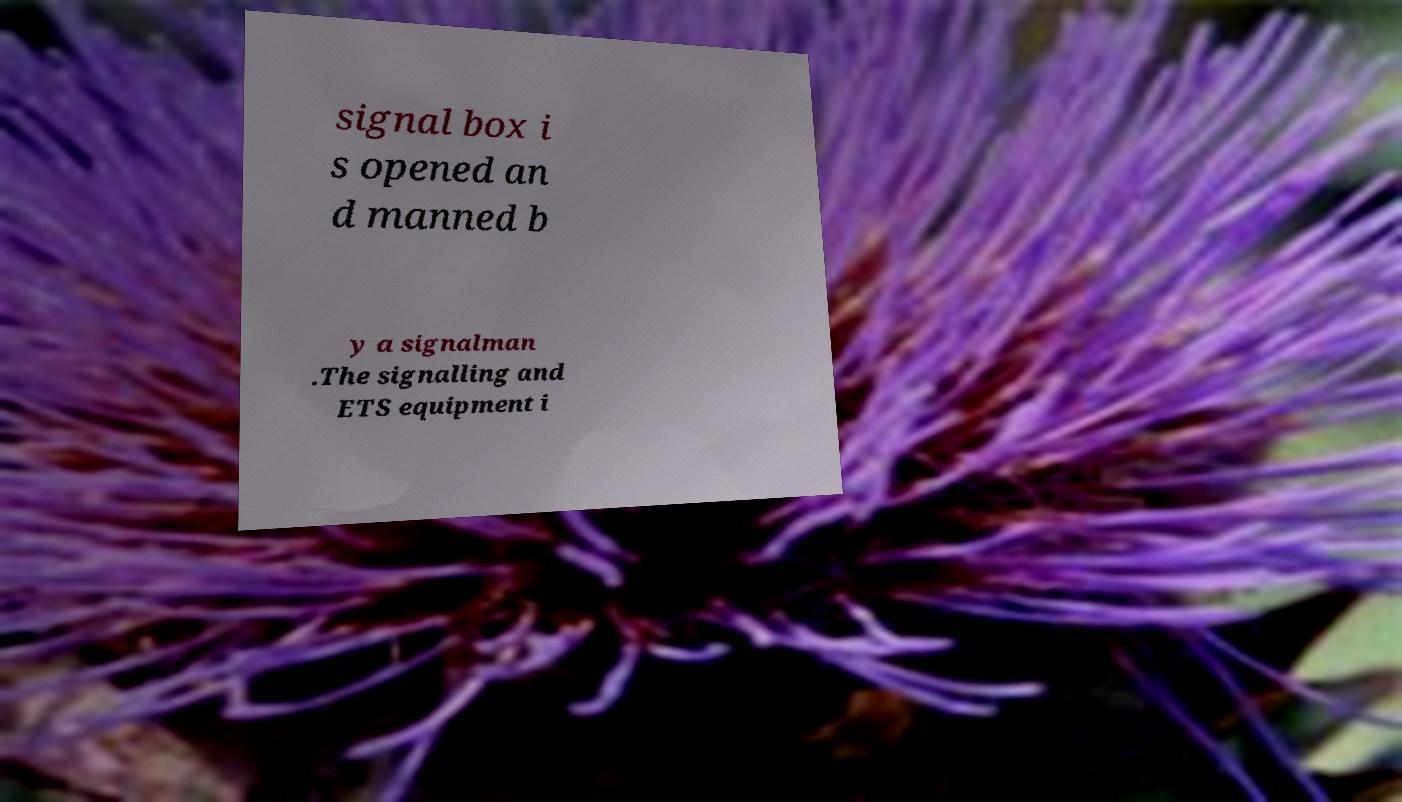There's text embedded in this image that I need extracted. Can you transcribe it verbatim? signal box i s opened an d manned b y a signalman .The signalling and ETS equipment i 